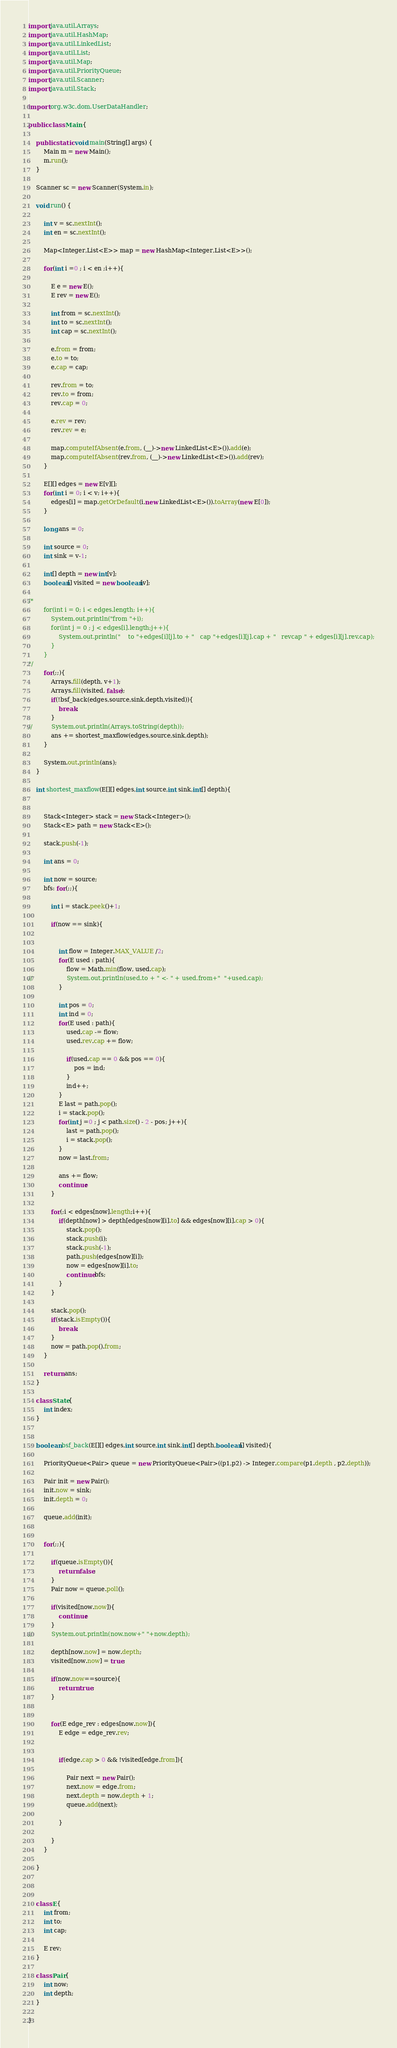<code> <loc_0><loc_0><loc_500><loc_500><_Java_>
import java.util.Arrays;
import java.util.HashMap;
import java.util.LinkedList;
import java.util.List;
import java.util.Map;
import java.util.PriorityQueue;
import java.util.Scanner;
import java.util.Stack;

import org.w3c.dom.UserDataHandler;

public class Main {

	public static void main(String[] args) {
		Main m = new Main();
		m.run();
	}

	Scanner sc = new Scanner(System.in);

	void run() {

		int v = sc.nextInt();
		int en = sc.nextInt();
		
		Map<Integer,List<E>> map = new HashMap<Integer,List<E>>();
		
		for(int i =0 ; i < en ;i++){
			
			E e = new E();
			E rev = new E();
			
			int from = sc.nextInt();
			int to = sc.nextInt();
			int cap = sc.nextInt();
			
			e.from = from;
			e.to = to;
			e.cap = cap;
			
			rev.from = to;
			rev.to = from;
			rev.cap = 0;
			
			e.rev = rev;
			rev.rev = e;
			
			map.computeIfAbsent(e.from, (__)->new LinkedList<E>()).add(e);
			map.computeIfAbsent(rev.from, (__)->new LinkedList<E>()).add(rev);			
		}
		
		E[][] edges = new E[v][];
		for(int i = 0; i < v; i++){
			edges[i] = map.getOrDefault(i,new LinkedList<E>()).toArray(new E[0]);
		}
		
		long ans = 0;
		
		int source = 0;
		int sink = v-1;
		
		int[] depth = new int[v];
		boolean[] visited = new boolean[v];
		
/*
 		for(int i = 0; i < edges.length; i++){
			System.out.println("from "+i);
			for(int j = 0 ; j < edges[i].length;j++){
				System.out.println("    to "+edges[i][j].to + "   cap "+edges[i][j].cap + "   revcap " + edges[i][j].rev.cap);
			}
		}
*/
		for(;;){	
			Arrays.fill(depth, v+1);
			Arrays.fill(visited, false);
			if(!bsf_back(edges,source,sink,depth,visited)){
				break;
			}
//			System.out.println(Arrays.toString(depth));
			ans += shortest_maxflow(edges,source,sink,depth);
		}
		
		System.out.println(ans);
	}
	
	int shortest_maxflow(E[][] edges,int source,int sink,int[] depth){
		
		
		Stack<Integer> stack = new Stack<Integer>();
		Stack<E> path = new Stack<E>();
		
		stack.push(-1);
		
		int ans = 0;
		
		int now = source;
		bfs: for(;;){	

			int i = stack.peek()+1;
			
			if(now == sink){
				
				
				int flow = Integer.MAX_VALUE /2;
				for(E used : path){
					flow = Math.min(flow, used.cap);
//					System.out.println(used.to + " <- " + used.from+"  "+used.cap);
				}
				
				int pos = 0;
				int ind = 0;
				for(E used : path){
					used.cap -= flow;
					used.rev.cap += flow;

					if(used.cap == 0 && pos == 0){
						pos = ind;
					}
					ind++;
				}
				E last = path.pop();
				i = stack.pop();
				for(int j =0 ; j < path.size() - 2 - pos; j++){
					last = path.pop();
					i = stack.pop();
				}
				now = last.from;		
				
				ans += flow;
				continue;
			}
			
			for(;i < edges[now].length;i++){
				if(depth[now] > depth[edges[now][i].to] && edges[now][i].cap > 0){
					stack.pop();
					stack.push(i);
					stack.push(-1);
					path.push(edges[now][i]);
					now = edges[now][i].to;
					continue bfs;
				}				
			}
			
			stack.pop();
			if(stack.isEmpty()){
				break;
			}
			now = path.pop().from;
		}
		
		return ans;
	}
	
	class State{
		int index;
	}
	
	
	boolean bsf_back(E[][] edges,int source,int sink,int[] depth,boolean[] visited){
		
		PriorityQueue<Pair> queue = new PriorityQueue<Pair>((p1,p2) -> Integer.compare(p1.depth , p2.depth));
		
		Pair init = new Pair();
		init.now = sink;
		init.depth = 0;
		
		queue.add(init);
		
		
		for(;;){
			
			if(queue.isEmpty()){
				return false;
			}
			Pair now = queue.poll();
			
			if(visited[now.now]){
				continue;
			}
//			System.out.println(now.now+" "+now.depth);
			
			depth[now.now] = now.depth;
			visited[now.now] = true;
			
			if(now.now==source){
				return true;
			}
			
			
			for(E edge_rev : edges[now.now]){
				E edge = edge_rev.rev;
				
				
				if(edge.cap > 0 && !visited[edge.from]){
					
					Pair next = new Pair();
					next.now = edge.from;
					next.depth = now.depth + 1;
					queue.add(next);
					
				}
							
			}
		}
		
	}
	
	
	
	class E{
		int from;
		int to;
		int cap;
		
		E rev;
	}
	
	class Pair{
		int now;
		int depth;
	}
	
}
</code> 